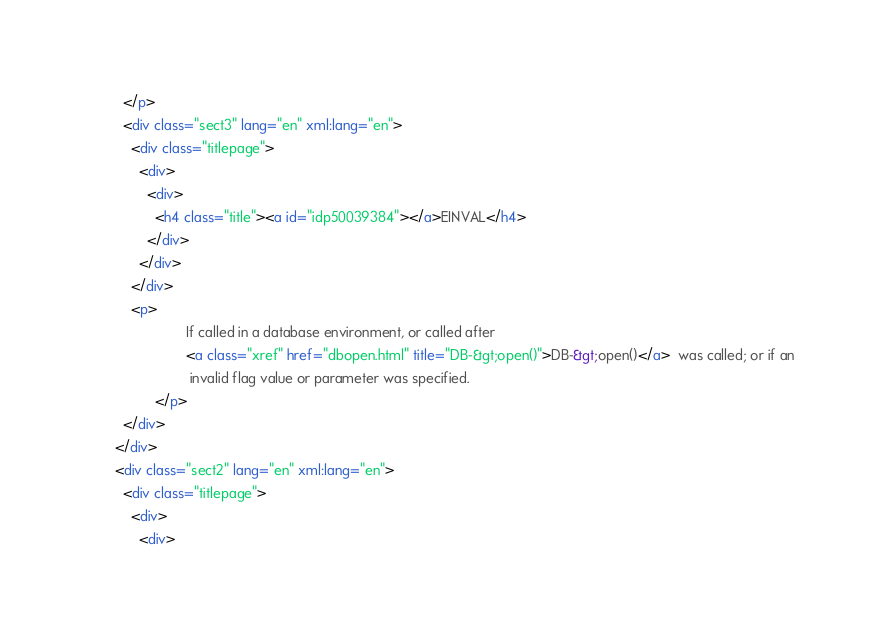<code> <loc_0><loc_0><loc_500><loc_500><_HTML_>        </p>
        <div class="sect3" lang="en" xml:lang="en">
          <div class="titlepage">
            <div>
              <div>
                <h4 class="title"><a id="idp50039384"></a>EINVAL</h4>
              </div>
            </div>
          </div>
          <p>
                        If called in a database environment, or called after 
                        <a class="xref" href="dbopen.html" title="DB-&gt;open()">DB-&gt;open()</a>  was called; or if an
                         invalid flag value or parameter was specified.
                </p>
        </div>
      </div>
      <div class="sect2" lang="en" xml:lang="en">
        <div class="titlepage">
          <div>
            <div></code> 